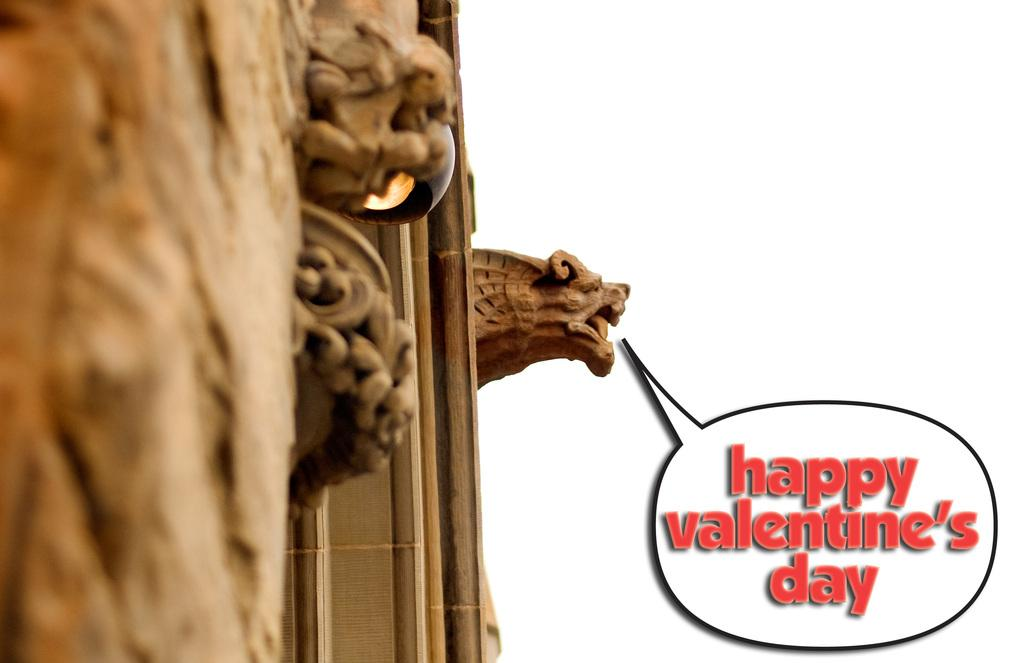What material is used to construct the wall in the image? The wall in the image is made of wood. What decorative element is present on the wall? There is a sculpture of a lion on the wall. What is located to the right of the lion sculpture? There is text to the right of the sculpture. What type of toothbrush is being used to clean the lion sculpture in the image? There is no toothbrush present in the image, and the lion sculpture is not being cleaned. 